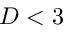Convert formula to latex. <formula><loc_0><loc_0><loc_500><loc_500>D < 3</formula> 